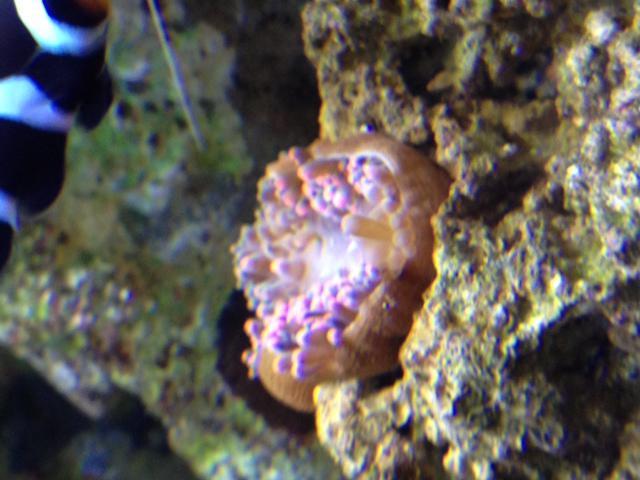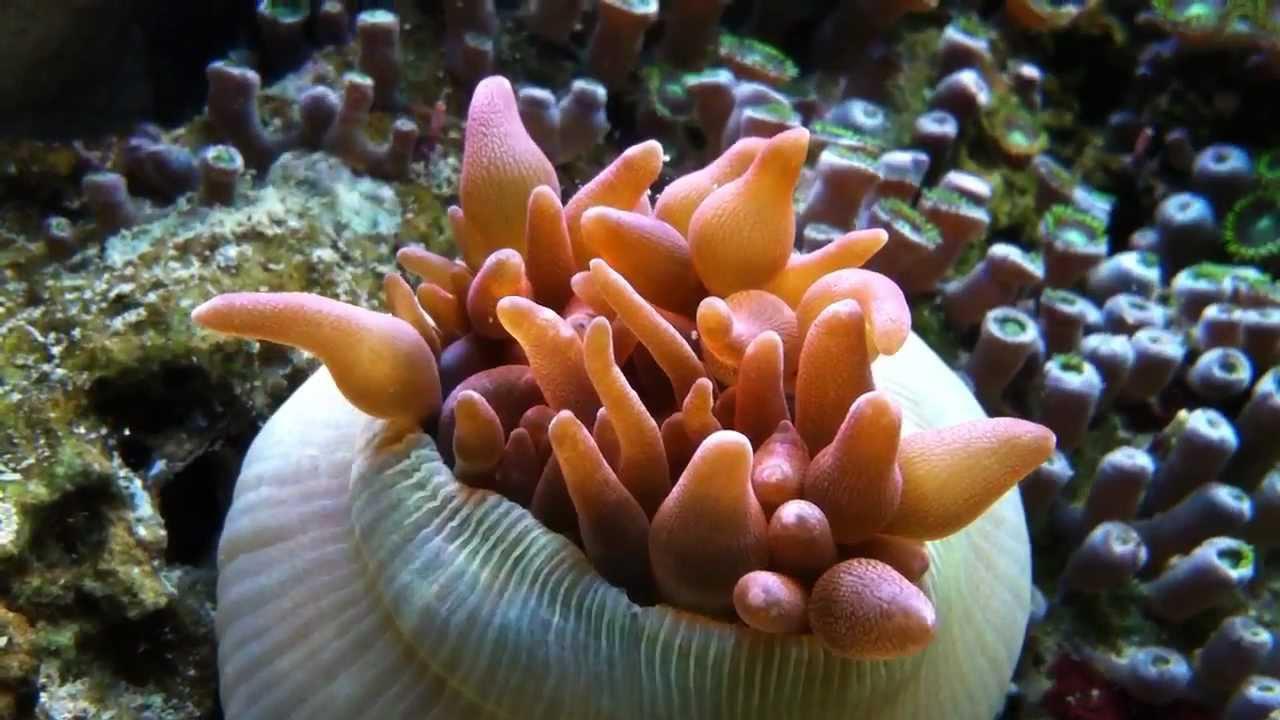The first image is the image on the left, the second image is the image on the right. Given the left and right images, does the statement "Some elements of the coral are pink in at least one of the images." hold true? Answer yes or no. Yes. The first image is the image on the left, the second image is the image on the right. For the images displayed, is the sentence "An image shows brownish anemone tendrils emerging from a rounded, inflated looking purplish sac." factually correct? Answer yes or no. No. 